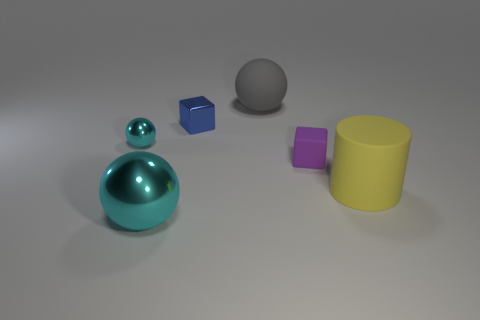Which object is closest to the camera? The turquoise teardrop-shaped object is closest to the camera. It is positioned in the foreground, larger in perspective compared to the other objects, indicating its proximity. Is there a pattern in how the objects are arranged? The objects are arranged in no particular pattern; they seem to be placed randomly across the plane. There's a mix of shapes and colors with no repetition or symmetry that would suggest a deliberate pattern. 